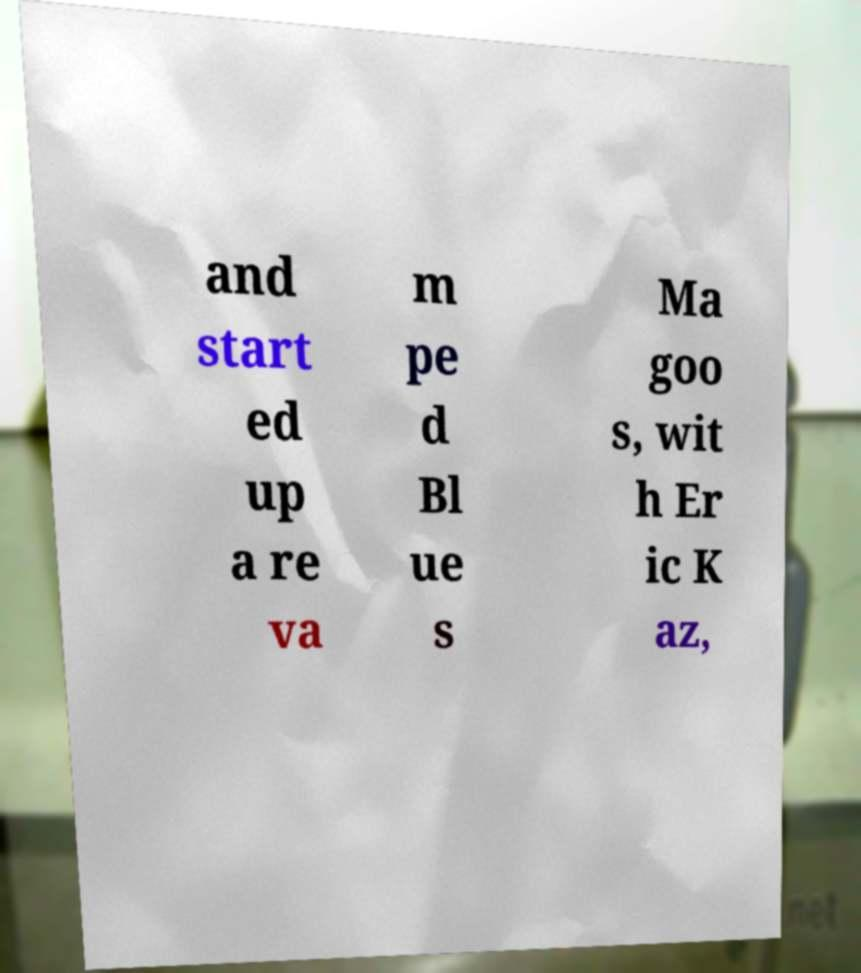For documentation purposes, I need the text within this image transcribed. Could you provide that? and start ed up a re va m pe d Bl ue s Ma goo s, wit h Er ic K az, 